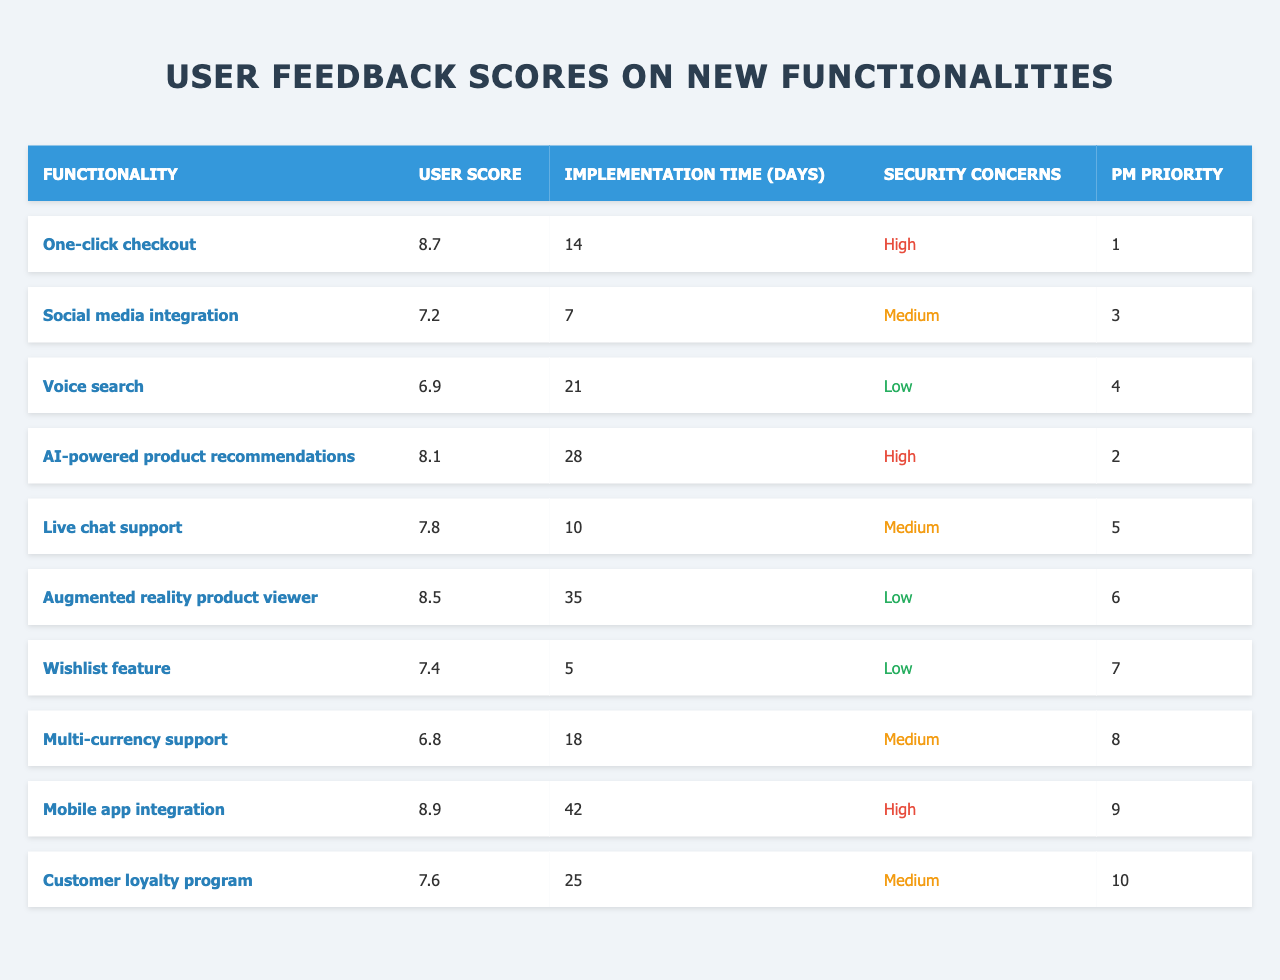What is the user score for the "Mobile app integration" functionality? The table lists user scores for each functionality. For "Mobile app integration", the score is found directly in the table under the "User Score" column.
Answer: 8.9 Which functionality has the lowest user score? The table lists all user scores. By comparing the scores, the lowest one is "Multi-currency support" at 6.8.
Answer: Multi-currency support What is the implementation time for "One-click checkout"? The implementation time is listed directly in the table under the "Implementation Time (days)" column for "One-click checkout". It shows 14 days.
Answer: 14 How many functionalities have a user score higher than 8? By reviewing the user score column, only "One-click checkout", "AI-powered product recommendations", "Augmented reality product viewer", and "Mobile app integration" have scores above 8. That makes 4 functionalities.
Answer: 4 What is the average user score for the functionalities with "High" security concerns? The user scores for functionalities with "High" security concerns are 8.7 (One-click checkout), 8.1 (AI-powered product recommendations), and 8.9 (Mobile app integration). To find the average, we sum these scores: 8.7 + 8.1 + 8.9 = 25.7. Then divide by the number of functionalities (3), which gives us 25.7 / 3 = 8.566.
Answer: 8.566 Is there any functionality that has a "Low" security concern and a higher user score than 8? By examining the table, "Augmented reality product viewer" is the only functionality with a "Low" security concern that also has a user score of 8.5, which is higher than 8.
Answer: Yes Which functionality has both a high user score and high implementation time? Reviewing the table, "Mobile app integration" has a user score of 8.9 and the highest implementation time of 42 days.
Answer: Mobile app integration What security concerns are associated with the functionality that has the highest user score? "Mobile app integration" has the highest user score of 8.9, and according to the table, it has "High" security concerns.
Answer: High How does the total implementation time of the top three functionalities by user score compare to the total implementation time of the bottom three? The implementation times for the top three functionalities (8.9 for Mobile app integration, 8.7 for One-click checkout, and 8.5 for Augmented reality product viewer) are 42, 14, and 35 days respectively, totaling 91 days. For the bottom three functionalities (7.4 for Wishlist feature, 6.9 for Voice search, and 6.8 for Multi-currency support), the times are 5, 21, and 18 days, totaling 44 days. Comparing the two, 91 days is greater than 44 days.
Answer: 91 > 44 Are there any functionalities with a user score between 7 and 8 that have a security concern rated as "Medium"? Looking at the table, "Social media integration" with a score of 7.2 and "Live chat support" with a score of 7.8 both have "Medium" security concerns. There are indeed functionalities that fit this criterion.
Answer: Yes 